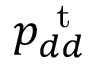Convert formula to latex. <formula><loc_0><loc_0><loc_500><loc_500>p _ { d d } ^ { t }</formula> 